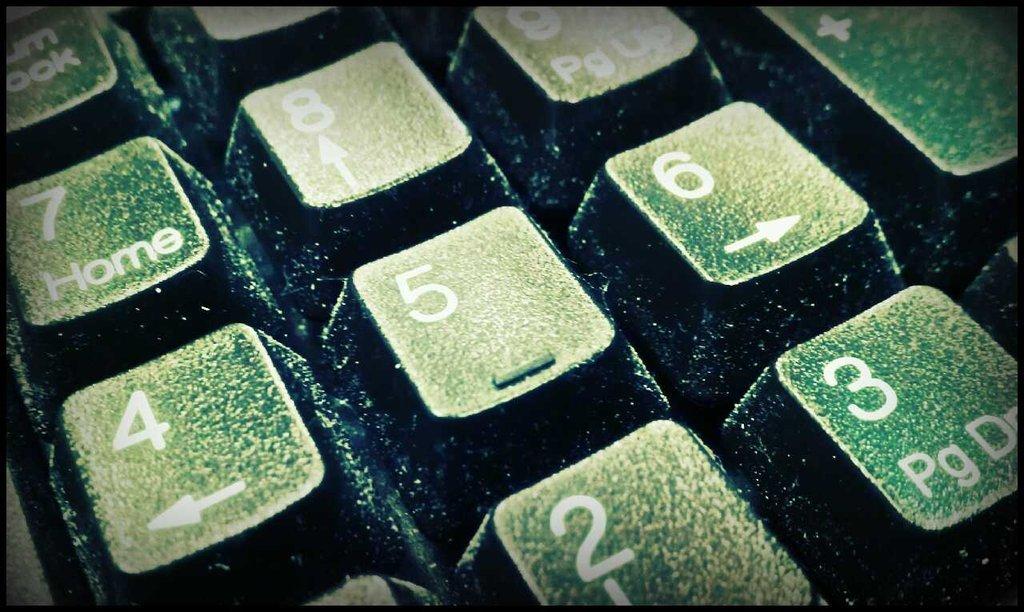What is the middle number?
Ensure brevity in your answer.  5. 